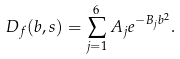<formula> <loc_0><loc_0><loc_500><loc_500>D _ { f } ( b , s ) = \sum _ { j = 1 } ^ { 6 } A _ { j } e ^ { - B _ { j } b ^ { 2 } } .</formula> 